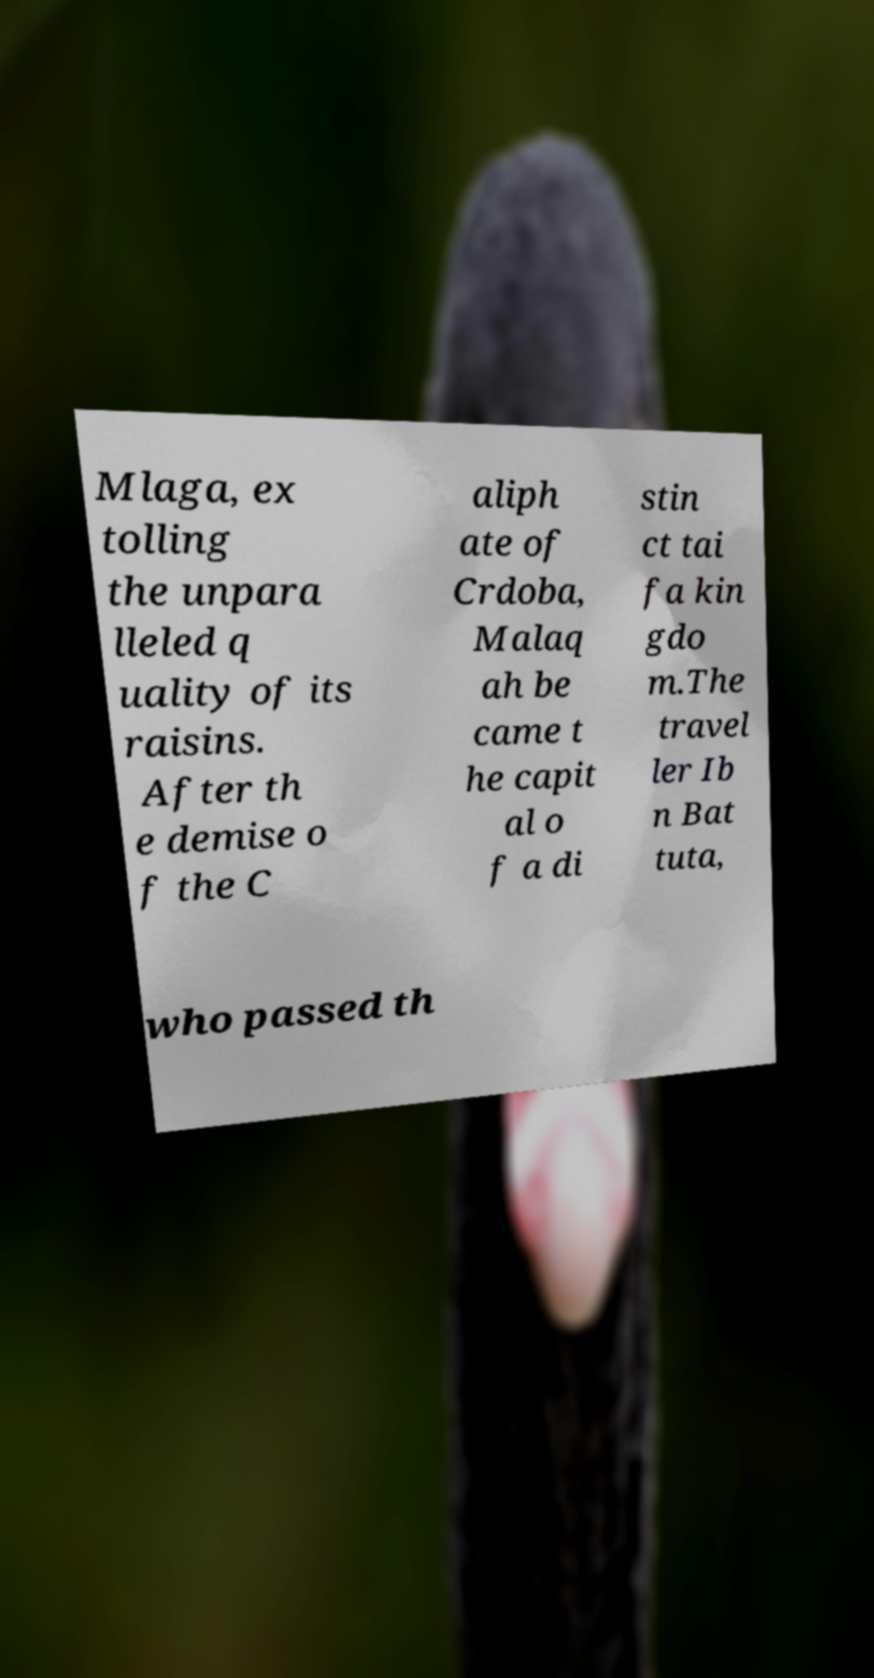Please read and relay the text visible in this image. What does it say? Mlaga, ex tolling the unpara lleled q uality of its raisins. After th e demise o f the C aliph ate of Crdoba, Malaq ah be came t he capit al o f a di stin ct tai fa kin gdo m.The travel ler Ib n Bat tuta, who passed th 